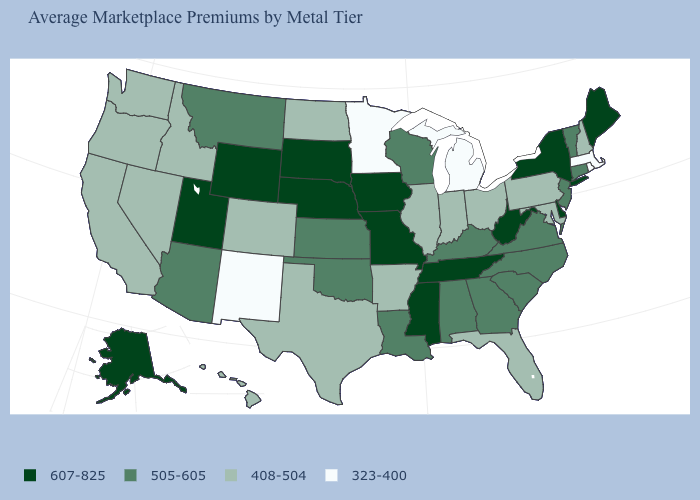Does the first symbol in the legend represent the smallest category?
Answer briefly. No. Among the states that border New York , does Connecticut have the highest value?
Answer briefly. Yes. What is the value of Vermont?
Short answer required. 505-605. What is the value of Kentucky?
Answer briefly. 505-605. How many symbols are there in the legend?
Quick response, please. 4. What is the value of California?
Short answer required. 408-504. Does West Virginia have the same value as Michigan?
Concise answer only. No. What is the value of Massachusetts?
Give a very brief answer. 323-400. What is the value of Pennsylvania?
Give a very brief answer. 408-504. What is the value of Arizona?
Keep it brief. 505-605. Does Oklahoma have the same value as Florida?
Concise answer only. No. Which states have the highest value in the USA?
Short answer required. Alaska, Delaware, Iowa, Maine, Mississippi, Missouri, Nebraska, New York, South Dakota, Tennessee, Utah, West Virginia, Wyoming. What is the value of Iowa?
Give a very brief answer. 607-825. Which states have the lowest value in the USA?
Answer briefly. Massachusetts, Michigan, Minnesota, New Mexico, Rhode Island. What is the lowest value in states that border Illinois?
Quick response, please. 408-504. 